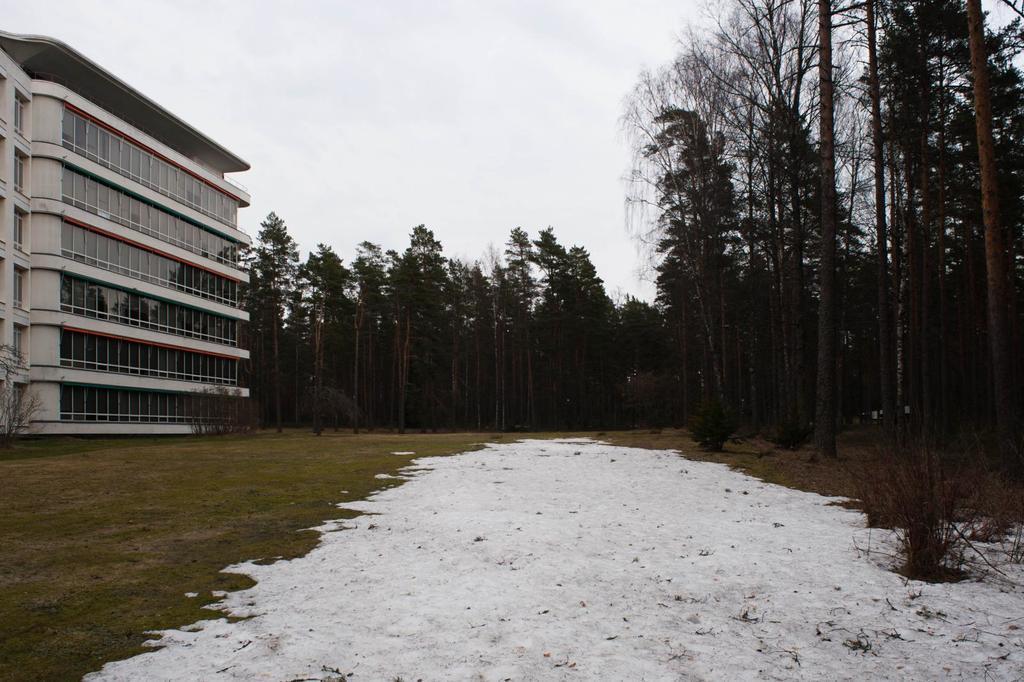Please provide a concise description of this image. On the left side of the image there is a building. On the right side of the image there are trees. In the background there is a sky. 